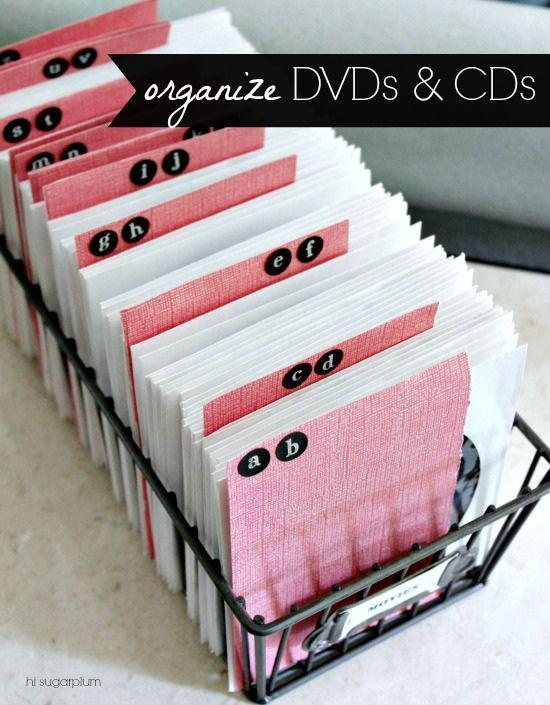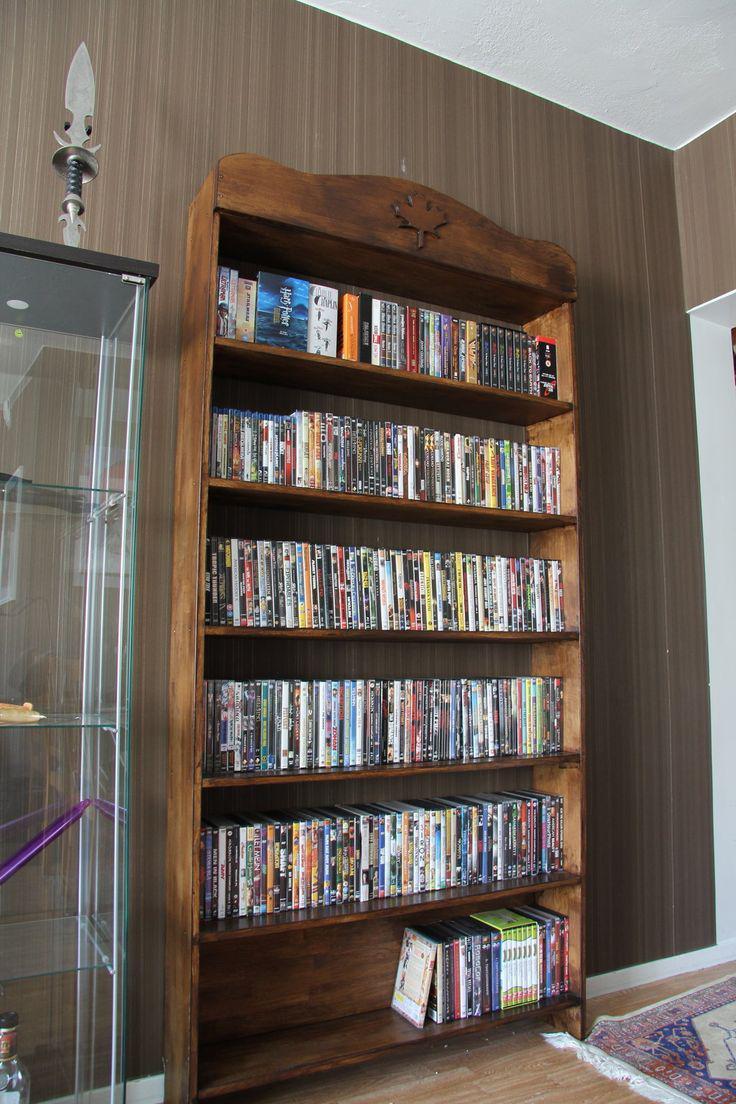The first image is the image on the left, the second image is the image on the right. Examine the images to the left and right. Is the description "In one image, a wooden book shelf with six shelves is standing against a wall." accurate? Answer yes or no. Yes. The first image is the image on the left, the second image is the image on the right. Analyze the images presented: Is the assertion "A bookshelf with 5 shelves is standing by a wall." valid? Answer yes or no. Yes. 